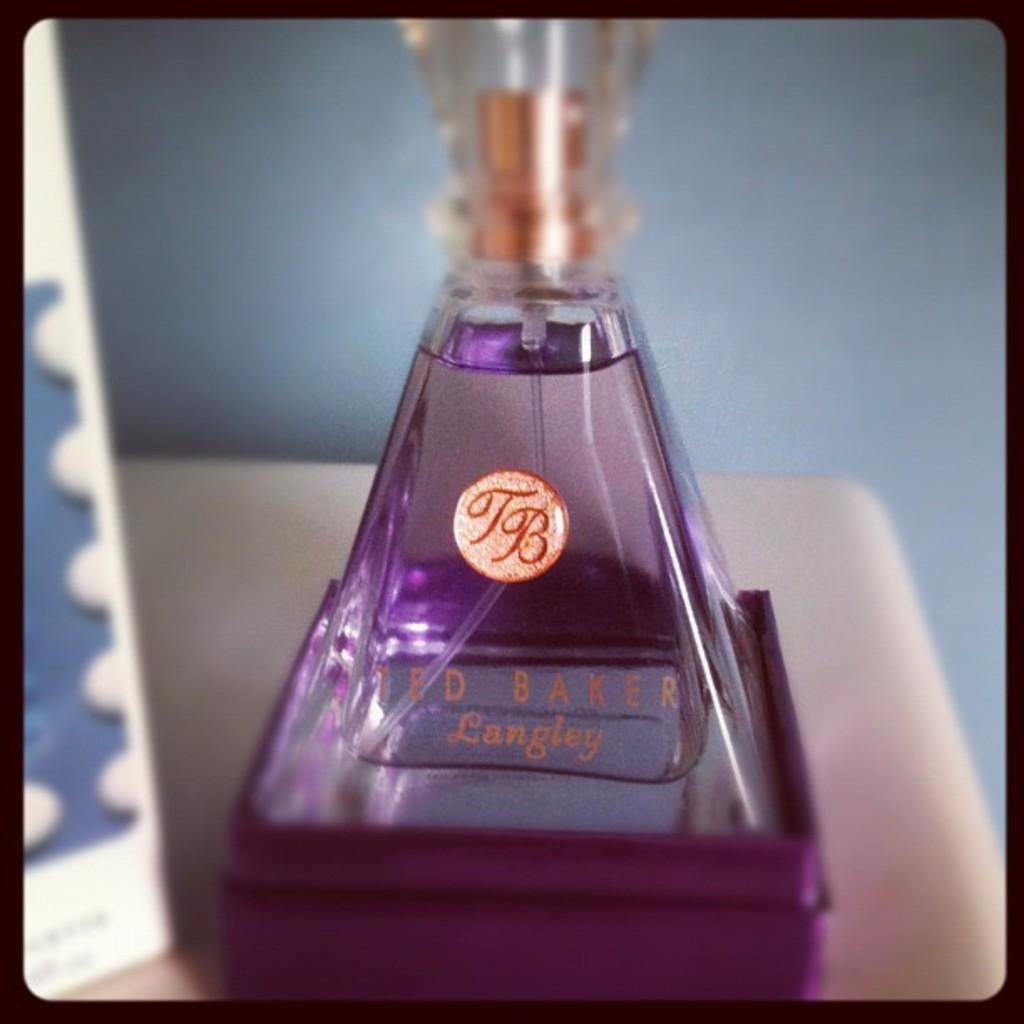Provide a one-sentence caption for the provided image. A product from Ted Baker Langley is in a pyramid shaped container. 